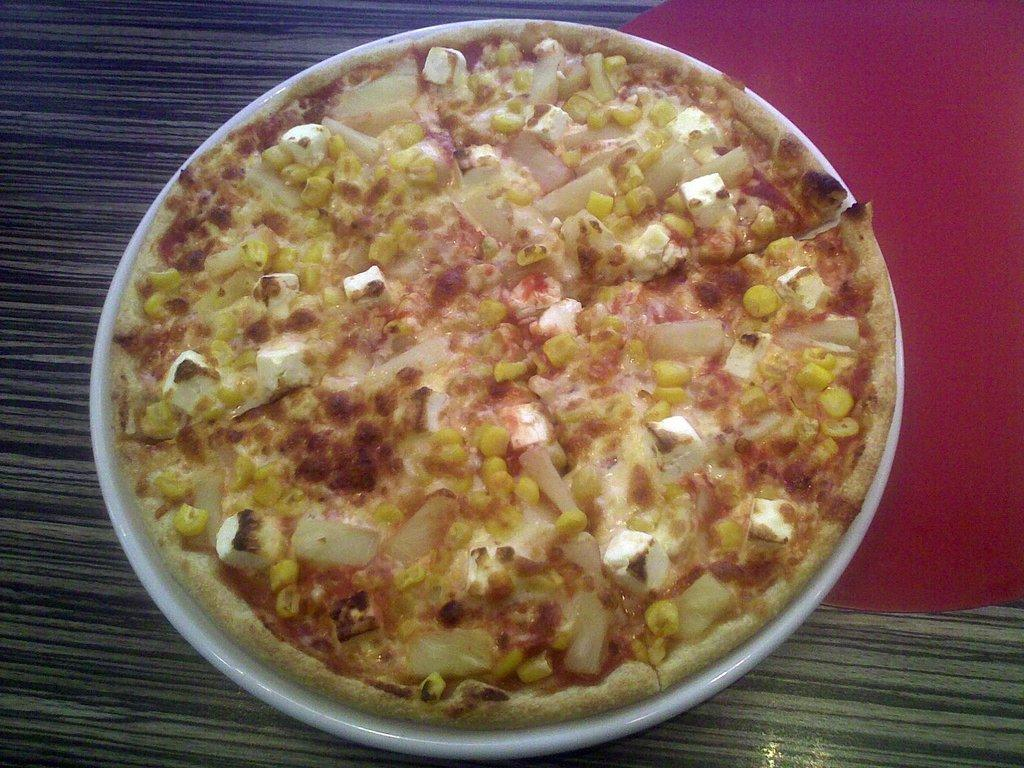What is in the white bowl in the image? There are food items in a white bowl in the image. Where is the bowl located? The bowl is placed on a table. What can be seen on the table? There is a red cloth on the table. How many beetles can be seen crawling on the back of the bike in the image? There are no beetles or bikes present in the image. 